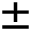Convert formula to latex. <formula><loc_0><loc_0><loc_500><loc_500>\pm</formula> 